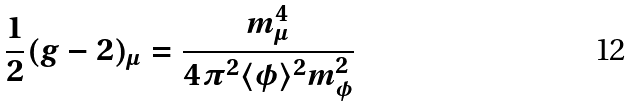<formula> <loc_0><loc_0><loc_500><loc_500>\frac { 1 } { 2 } ( g - 2 ) _ { \mu } = \frac { m _ { \mu } ^ { 4 } } { 4 \pi ^ { 2 } \langle \phi \rangle ^ { 2 } m _ { \phi } ^ { 2 } }</formula> 